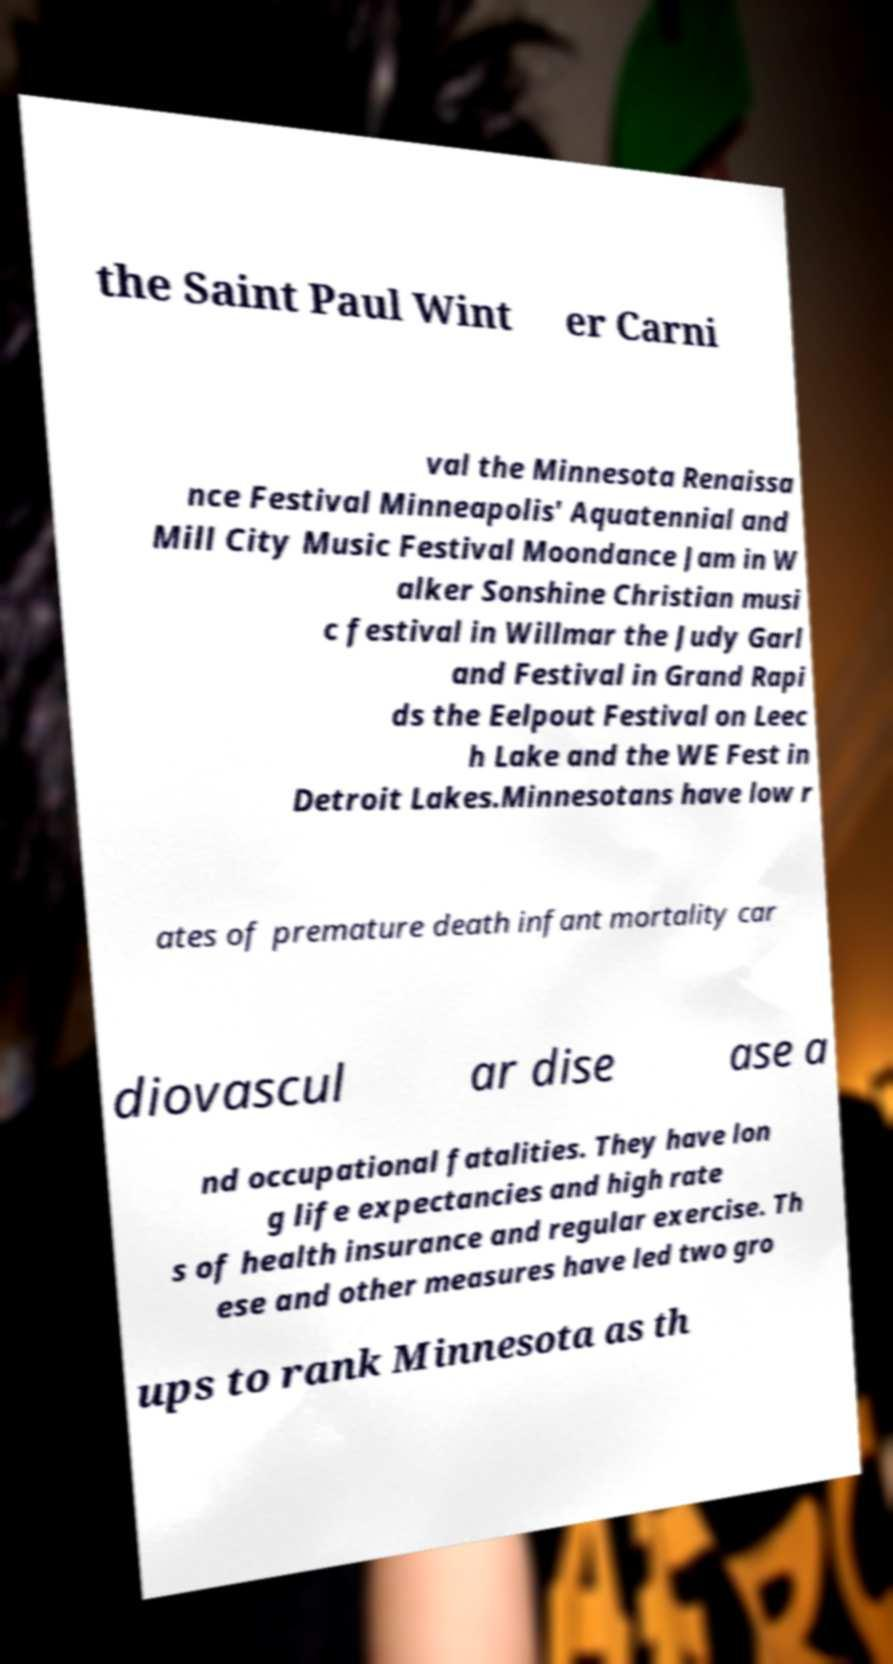There's text embedded in this image that I need extracted. Can you transcribe it verbatim? the Saint Paul Wint er Carni val the Minnesota Renaissa nce Festival Minneapolis' Aquatennial and Mill City Music Festival Moondance Jam in W alker Sonshine Christian musi c festival in Willmar the Judy Garl and Festival in Grand Rapi ds the Eelpout Festival on Leec h Lake and the WE Fest in Detroit Lakes.Minnesotans have low r ates of premature death infant mortality car diovascul ar dise ase a nd occupational fatalities. They have lon g life expectancies and high rate s of health insurance and regular exercise. Th ese and other measures have led two gro ups to rank Minnesota as th 